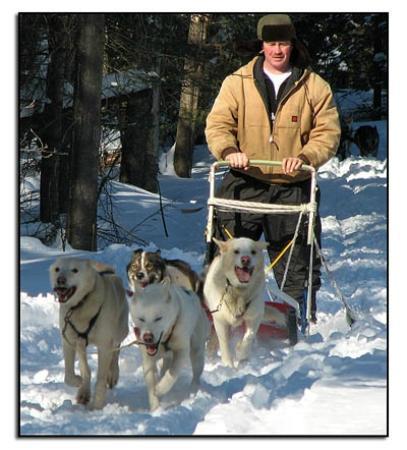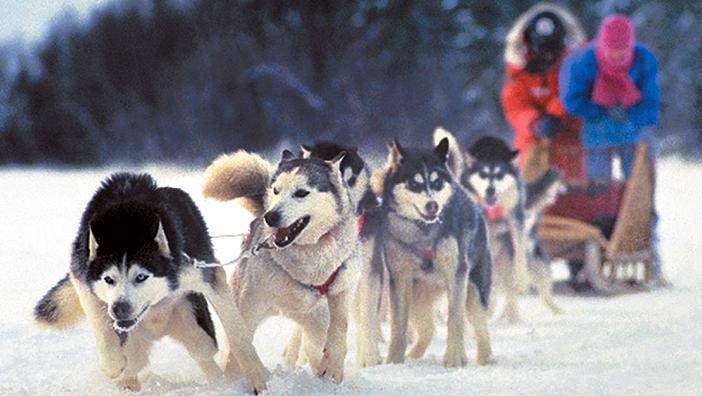The first image is the image on the left, the second image is the image on the right. For the images displayed, is the sentence "There are six dog pulling two people on the sled, over snow." factually correct? Answer yes or no. Yes. The first image is the image on the left, the second image is the image on the right. For the images displayed, is the sentence "One image features a sled dog team that is heading forward at an angle across a flattened snow path to the right." factually correct? Answer yes or no. No. 